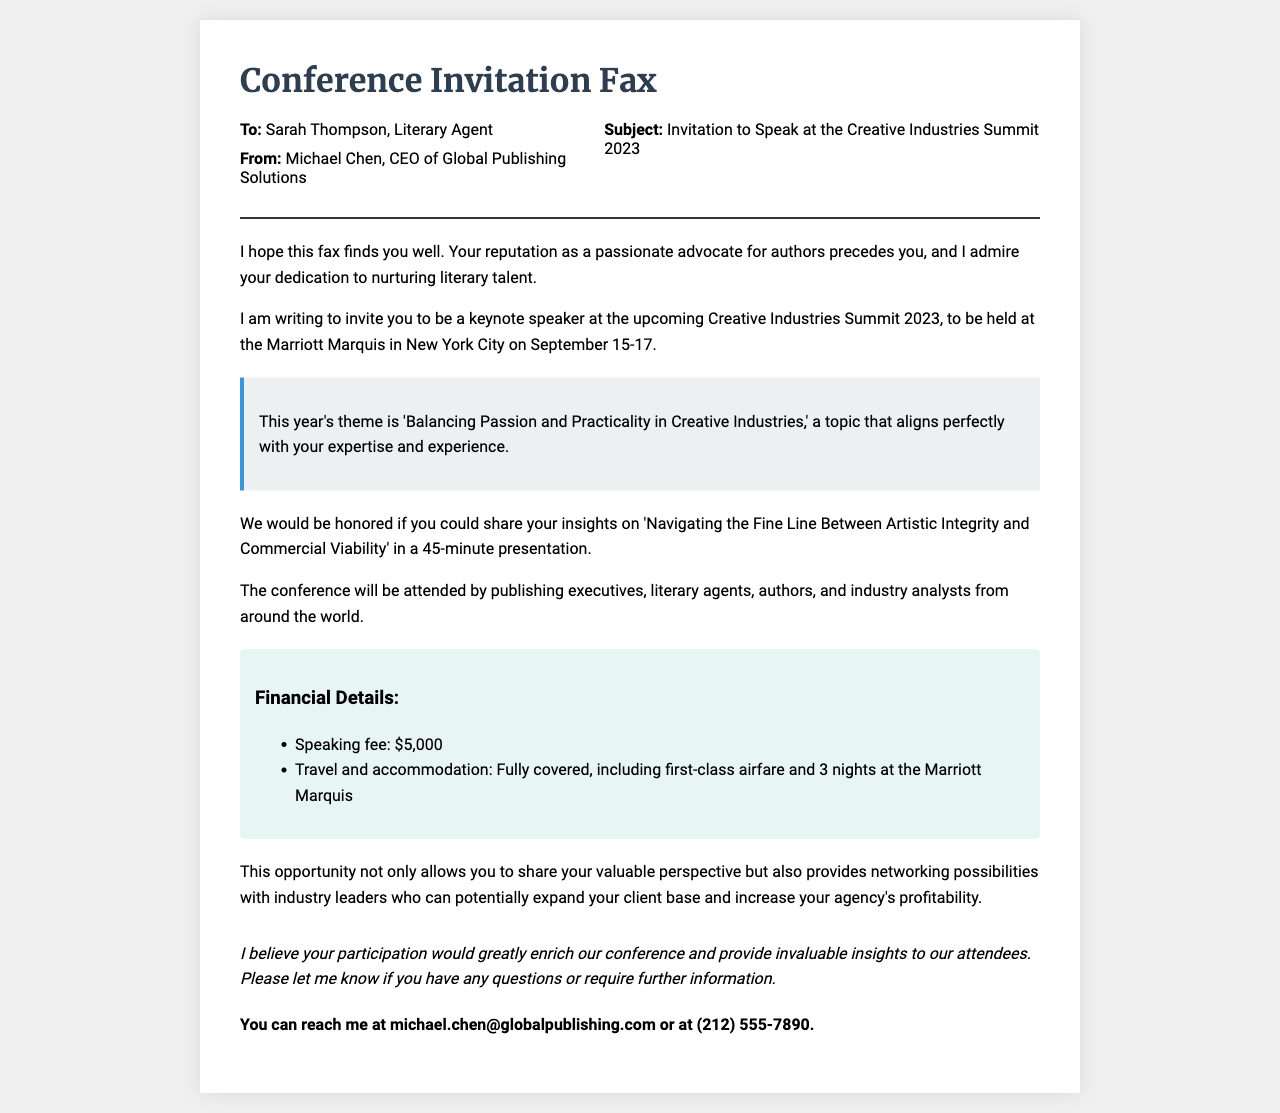what is the name of the conference? The document invites Sarah Thompson to a specific conference, which is named the Creative Industries Summit 2023.
Answer: Creative Industries Summit 2023 who is the sender of the fax? The sender of the fax is identified at the top, indicating that it is from Michael Chen.
Answer: Michael Chen what is the speaking fee mentioned in the document? The document lists the financial details, specifically stating that the speaking fee is $5,000.
Answer: $5,000 when will the conference take place? The document specifies the dates for the conference, which are September 15-17.
Answer: September 15-17 what is the theme of the conference? The theme of the conference is highlighted as 'Balancing Passion and Practicality in Creative Industries.'
Answer: Balancing Passion and Practicality in Creative Industries how long is the keynote presentation supposed to be? The document specifies the duration of the presentation, which is indicated to be 45 minutes.
Answer: 45 minutes where will the conference be held? The document mentions the venue for the conference, stating it will be at the Marriott Marquis in New York City.
Answer: Marriott Marquis in New York City what type of attendees will be present at the conference? The document mentions the type of attendees expected at the conference, which includes publishing executives, literary agents, authors, and industry analysts.
Answer: publishing executives, literary agents, authors, and industry analysts what is included in the travel and accommodation coverage? The financial details section of the document specifies that travel and accommodation include first-class airfare and 3 nights at the Marriott Marquis.
Answer: first-class airfare and 3 nights at the Marriott Marquis 